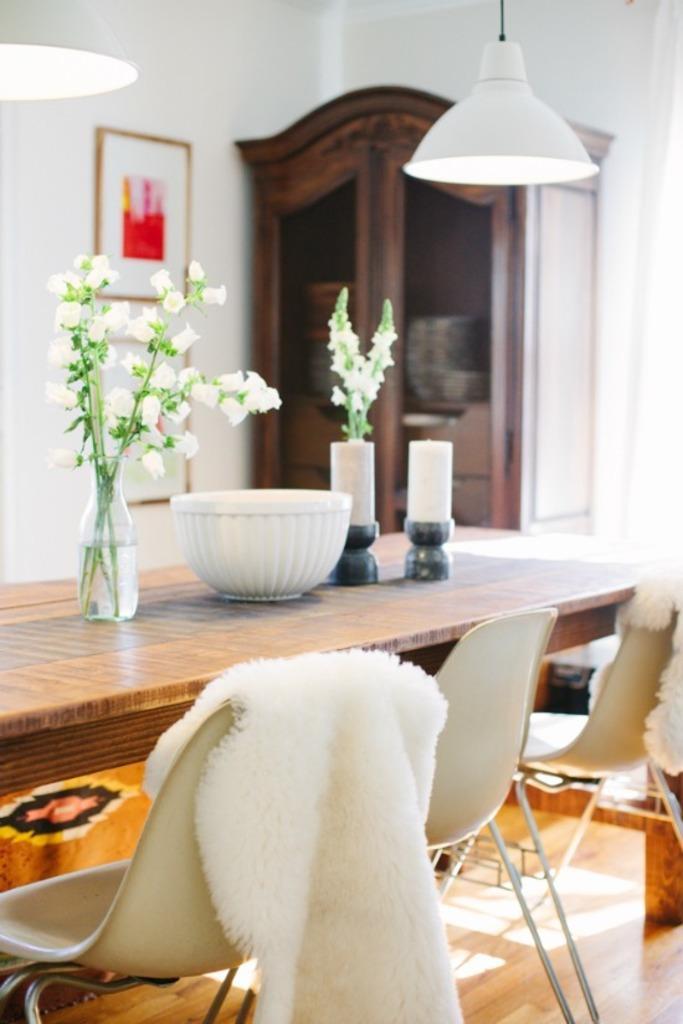Describe this image in one or two sentences. In this image I can see table and the chairs. on the chair there is a cloth and on the table there is a flower vase,bowl and some objects. In the background there is a cupboard and a frame to the wall. In the top there are lamps. 